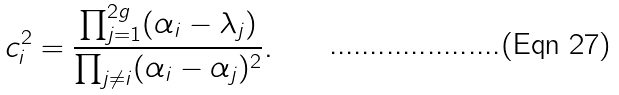<formula> <loc_0><loc_0><loc_500><loc_500>c _ { i } ^ { 2 } = \frac { \prod _ { j = 1 } ^ { 2 g } ( \alpha _ { i } - \lambda _ { j } ) } { \prod _ { j \neq i } ( \alpha _ { i } - \alpha _ { j } ) ^ { 2 } } .</formula> 